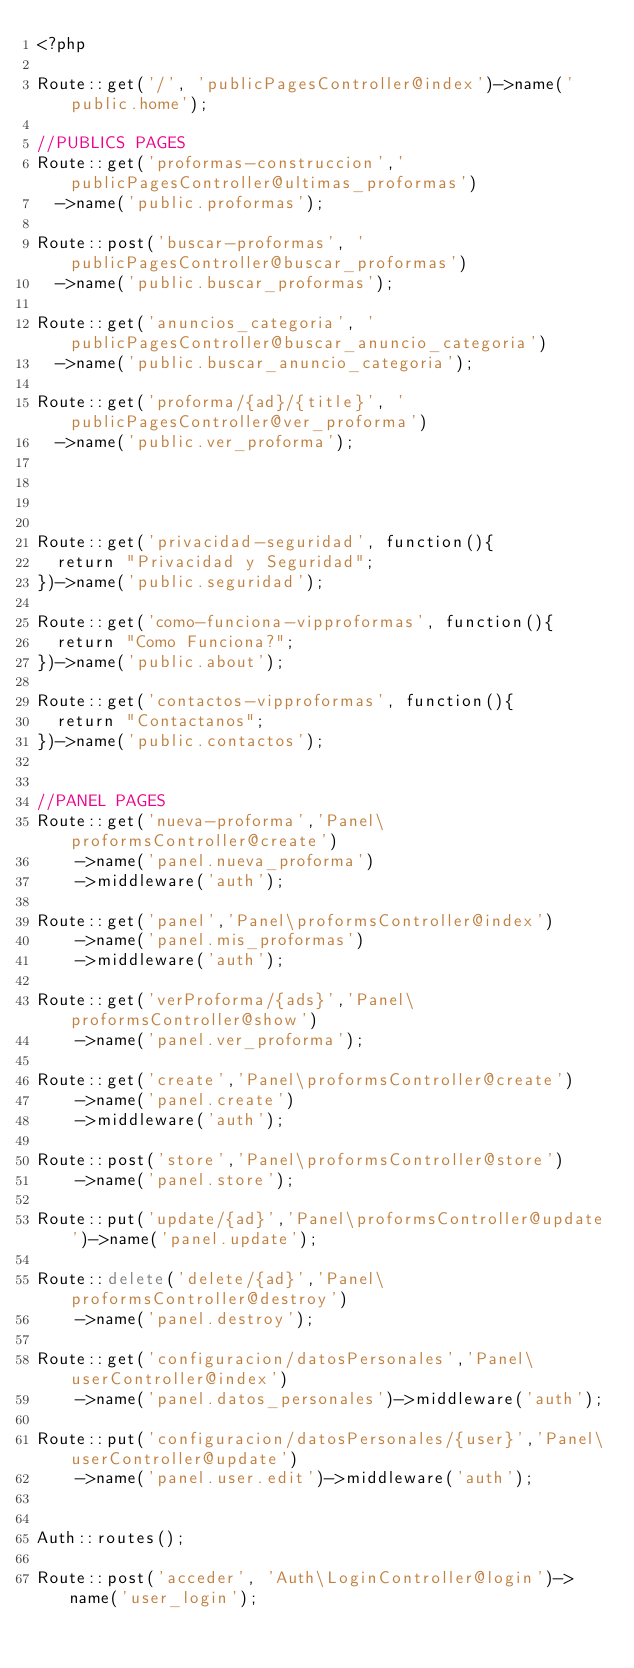<code> <loc_0><loc_0><loc_500><loc_500><_PHP_><?php

Route::get('/', 'publicPagesController@index')->name('public.home');

//PUBLICS PAGES
Route::get('proformas-construccion','publicPagesController@ultimas_proformas')
	->name('public.proformas');

Route::post('buscar-proformas', 'publicPagesController@buscar_proformas')
	->name('public.buscar_proformas');

Route::get('anuncios_categoria', 'publicPagesController@buscar_anuncio_categoria')
	->name('public.buscar_anuncio_categoria');

Route::get('proforma/{ad}/{title}', 'publicPagesController@ver_proforma')
	->name('public.ver_proforma');




Route::get('privacidad-seguridad', function(){
	return "Privacidad y Seguridad";
})->name('public.seguridad');

Route::get('como-funciona-vipproformas', function(){
	return "Como Funciona?";
})->name('public.about');

Route::get('contactos-vipproformas', function(){
	return "Contactanos";
})->name('public.contactos');


//PANEL PAGES
Route::get('nueva-proforma','Panel\proformsController@create')
		->name('panel.nueva_proforma')
		->middleware('auth');

Route::get('panel','Panel\proformsController@index')
		->name('panel.mis_proformas')
		->middleware('auth');

Route::get('verProforma/{ads}','Panel\proformsController@show')
		->name('panel.ver_proforma');

Route::get('create','Panel\proformsController@create')
		->name('panel.create')
		->middleware('auth');

Route::post('store','Panel\proformsController@store')
		->name('panel.store');

Route::put('update/{ad}','Panel\proformsController@update')->name('panel.update');

Route::delete('delete/{ad}','Panel\proformsController@destroy')
		->name('panel.destroy');

Route::get('configuracion/datosPersonales','Panel\userController@index')
		->name('panel.datos_personales')->middleware('auth');

Route::put('configuracion/datosPersonales/{user}','Panel\userController@update')
		->name('panel.user.edit')->middleware('auth');


Auth::routes();

Route::post('acceder', 'Auth\LoginController@login')->name('user_login');



</code> 